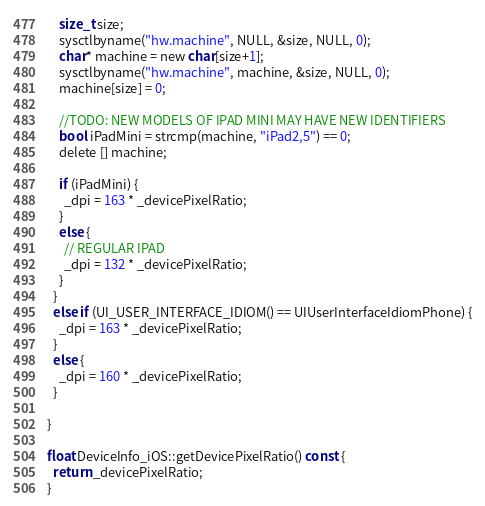<code> <loc_0><loc_0><loc_500><loc_500><_ObjectiveC_>    size_t size;
    sysctlbyname("hw.machine", NULL, &size, NULL, 0);
    char* machine = new char[size+1];
    sysctlbyname("hw.machine", machine, &size, NULL, 0);
    machine[size] = 0;

    //TODO: NEW MODELS OF IPAD MINI MAY HAVE NEW IDENTIFIERS
    bool iPadMini = strcmp(machine, "iPad2,5") == 0;
    delete [] machine;

    if (iPadMini) {
      _dpi = 163 * _devicePixelRatio;
    }
    else {
      // REGULAR IPAD
      _dpi = 132 * _devicePixelRatio;
    }
  }
  else if (UI_USER_INTERFACE_IDIOM() == UIUserInterfaceIdiomPhone) {
    _dpi = 163 * _devicePixelRatio;
  }
  else {
    _dpi = 160 * _devicePixelRatio;
  }

}

float DeviceInfo_iOS::getDevicePixelRatio() const {
  return _devicePixelRatio;
}
</code> 